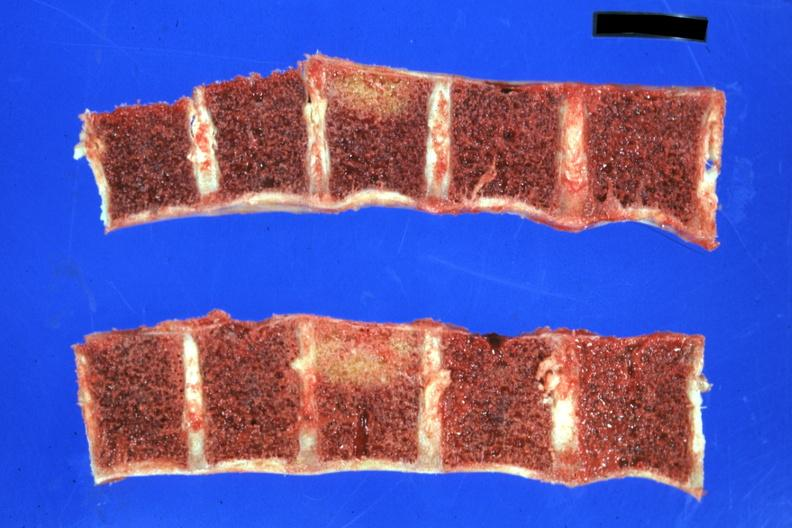s joints present?
Answer the question using a single word or phrase. Yes 